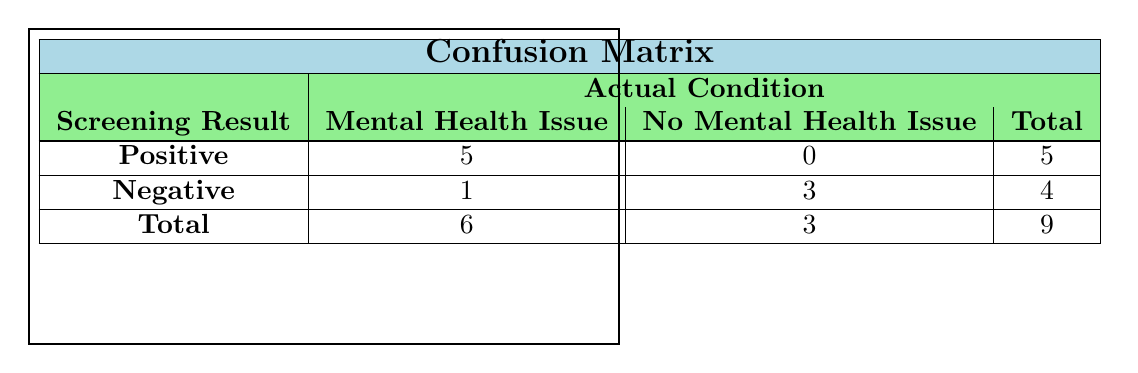What is the total number of patients screened? The table indicates there are a total of 9 patients when looking at the total row at the bottom.
Answer: 9 How many patients were identified as having a mental health issue? In the total row, the column for mental health issues shows a total of 6 patients.
Answer: 6 What is the number of patients who screened negative and had no mental health issues? Looking at the confusion matrix, the negative row's count for no mental health issues is 3, indicating these patients screened negative and had no issues.
Answer: 3 Is it true that all patients who screened positive had mental health issues? Referring to the table, it shows 5 patients screened positive and were identified as having mental health issues, and 0 were identified as having no issues, confirming the statement is true.
Answer: Yes What is the difference between the number of positive screening results and negative screening results? The confusion matrix shows 5 patients screened positive and 4 patients screened negative. The difference is 5 - 4 = 1.
Answer: 1 How many patients without mental health issues screened positive? The confusion matrix indicates that 0 patients without mental health issues screened positive, as seen in the corresponding cell in the positive row.
Answer: 0 What percentage of all patients who screened positive were diagnosed with a mental health issue? Of the 5 patients who screened positive, all 5 were identified with a mental health issue. To calculate the percentage, (5/5)*100 = 100%.
Answer: 100% What is the total number of false negatives (patients who had a condition but screened negative)? From the confusion matrix, 1 patient with a mental health issue screened negative, indicating a false negative.
Answer: 1 How many total patients diagnosed with mental health issues screened negative? The table shows that 1 patient who was diagnosed had a mental health issue but screened negative, as referenced in the negative row under the mental health issue column.
Answer: 1 